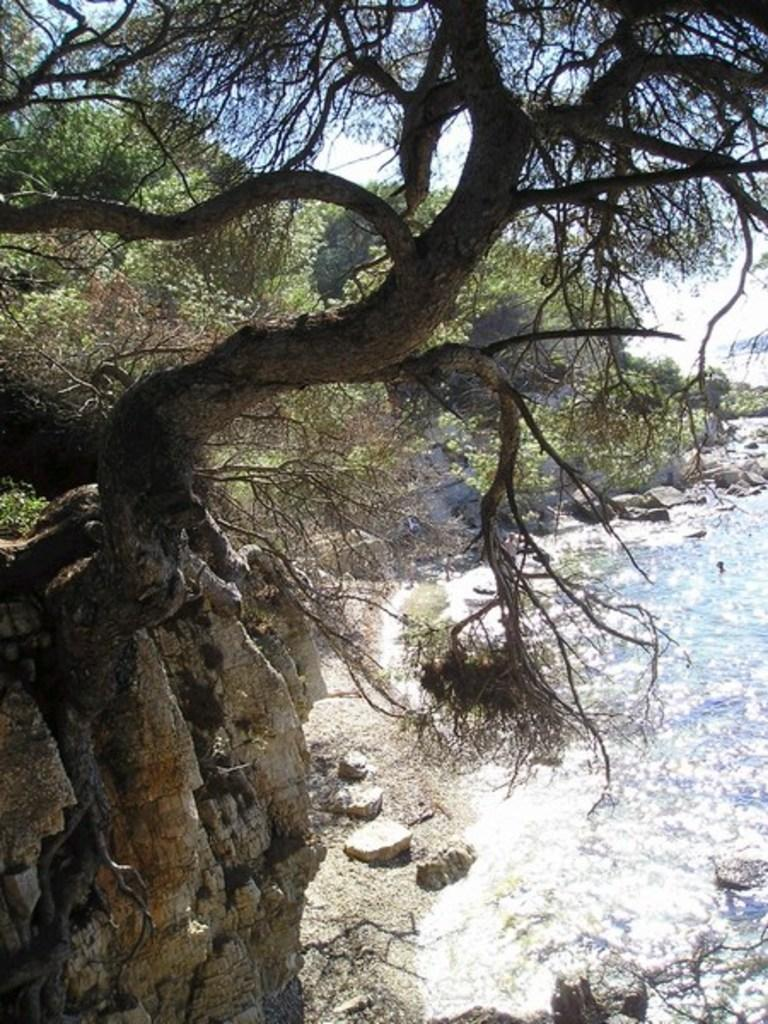Where was the picture taken? The picture was clicked outside. What can be seen in the foreground of the image? There is a water body and trees in the foreground. What is visible in the background of the image? The sky, trees, rocks, and other objects are visible in the background. What type of blade is being used by the turkey in the image? There is no turkey present in the image, and therefore no blade can be observed. 